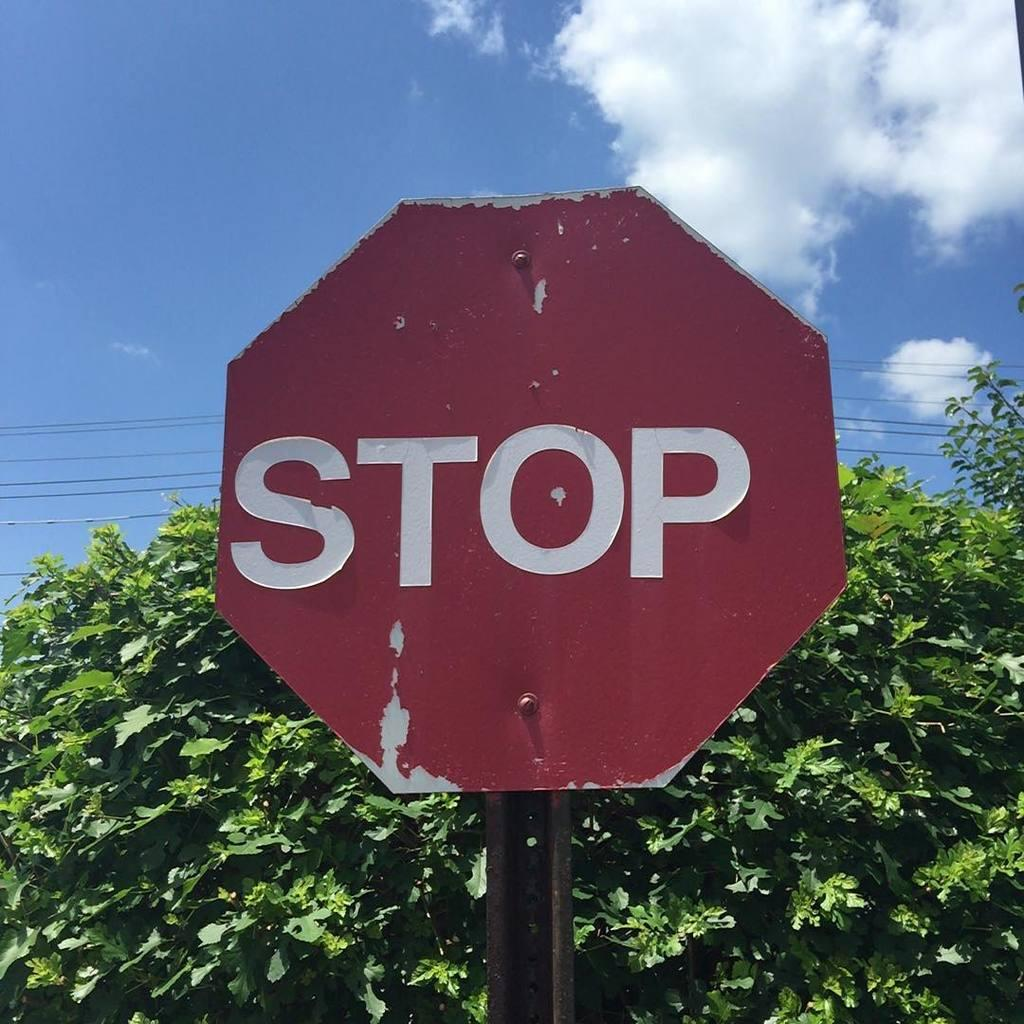<image>
Render a clear and concise summary of the photo. A battered stop sign with peeling paint in front of a tree. 